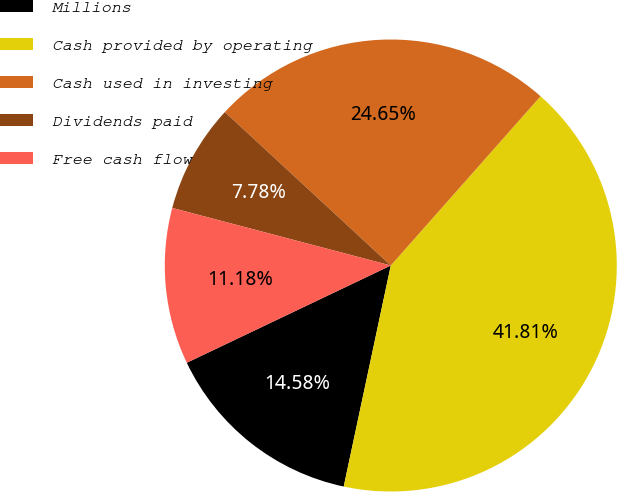Convert chart to OTSL. <chart><loc_0><loc_0><loc_500><loc_500><pie_chart><fcel>Millions<fcel>Cash provided by operating<fcel>Cash used in investing<fcel>Dividends paid<fcel>Free cash flow<nl><fcel>14.58%<fcel>41.81%<fcel>24.65%<fcel>7.78%<fcel>11.18%<nl></chart> 